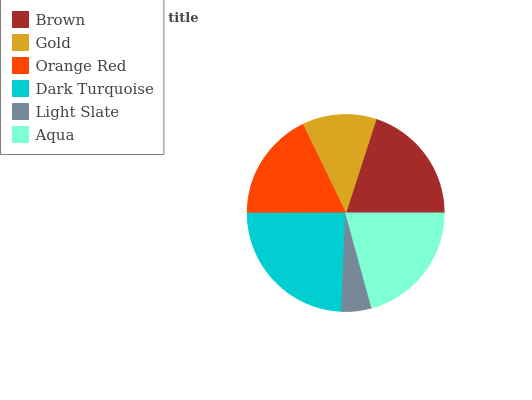Is Light Slate the minimum?
Answer yes or no. Yes. Is Dark Turquoise the maximum?
Answer yes or no. Yes. Is Gold the minimum?
Answer yes or no. No. Is Gold the maximum?
Answer yes or no. No. Is Brown greater than Gold?
Answer yes or no. Yes. Is Gold less than Brown?
Answer yes or no. Yes. Is Gold greater than Brown?
Answer yes or no. No. Is Brown less than Gold?
Answer yes or no. No. Is Brown the high median?
Answer yes or no. Yes. Is Orange Red the low median?
Answer yes or no. Yes. Is Orange Red the high median?
Answer yes or no. No. Is Dark Turquoise the low median?
Answer yes or no. No. 